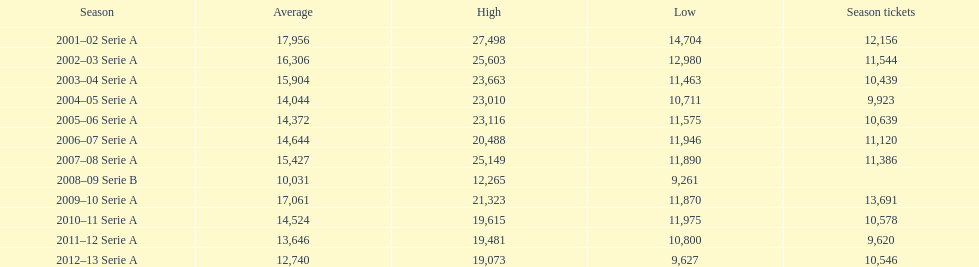How many seasons at the stadio ennio tardini had 11,000 or more season tickets? 5. 